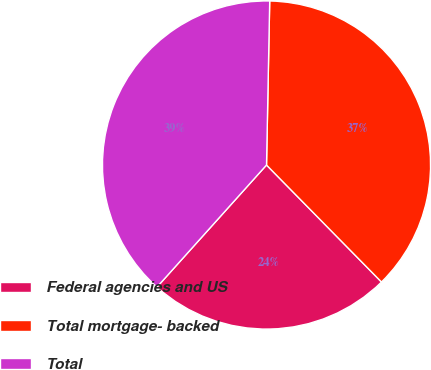<chart> <loc_0><loc_0><loc_500><loc_500><pie_chart><fcel>Federal agencies and US<fcel>Total mortgage- backed<fcel>Total<nl><fcel>24.0%<fcel>37.33%<fcel>38.67%<nl></chart> 